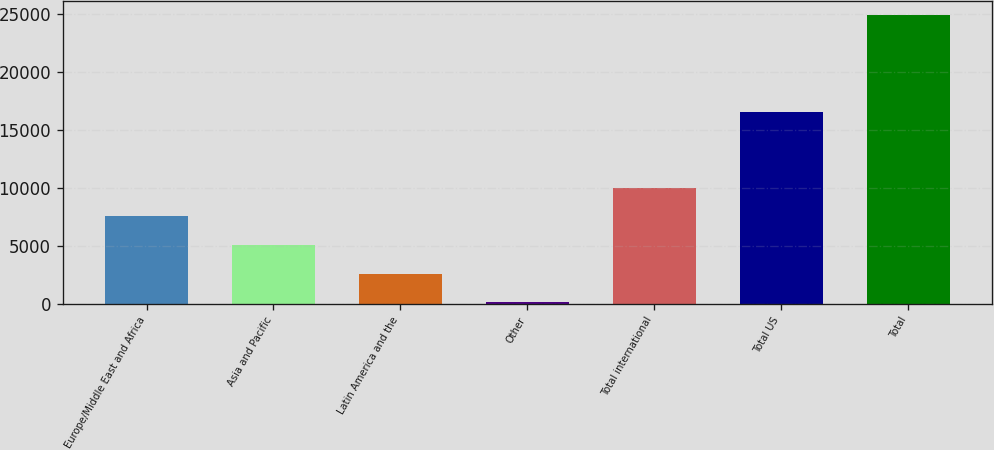Convert chart. <chart><loc_0><loc_0><loc_500><loc_500><bar_chart><fcel>Europe/Middle East and Africa<fcel>Asia and Pacific<fcel>Latin America and the<fcel>Other<fcel>Total international<fcel>Total US<fcel>Total<nl><fcel>7525.6<fcel>5049.4<fcel>2573.2<fcel>97<fcel>10001.8<fcel>16489<fcel>24859<nl></chart> 